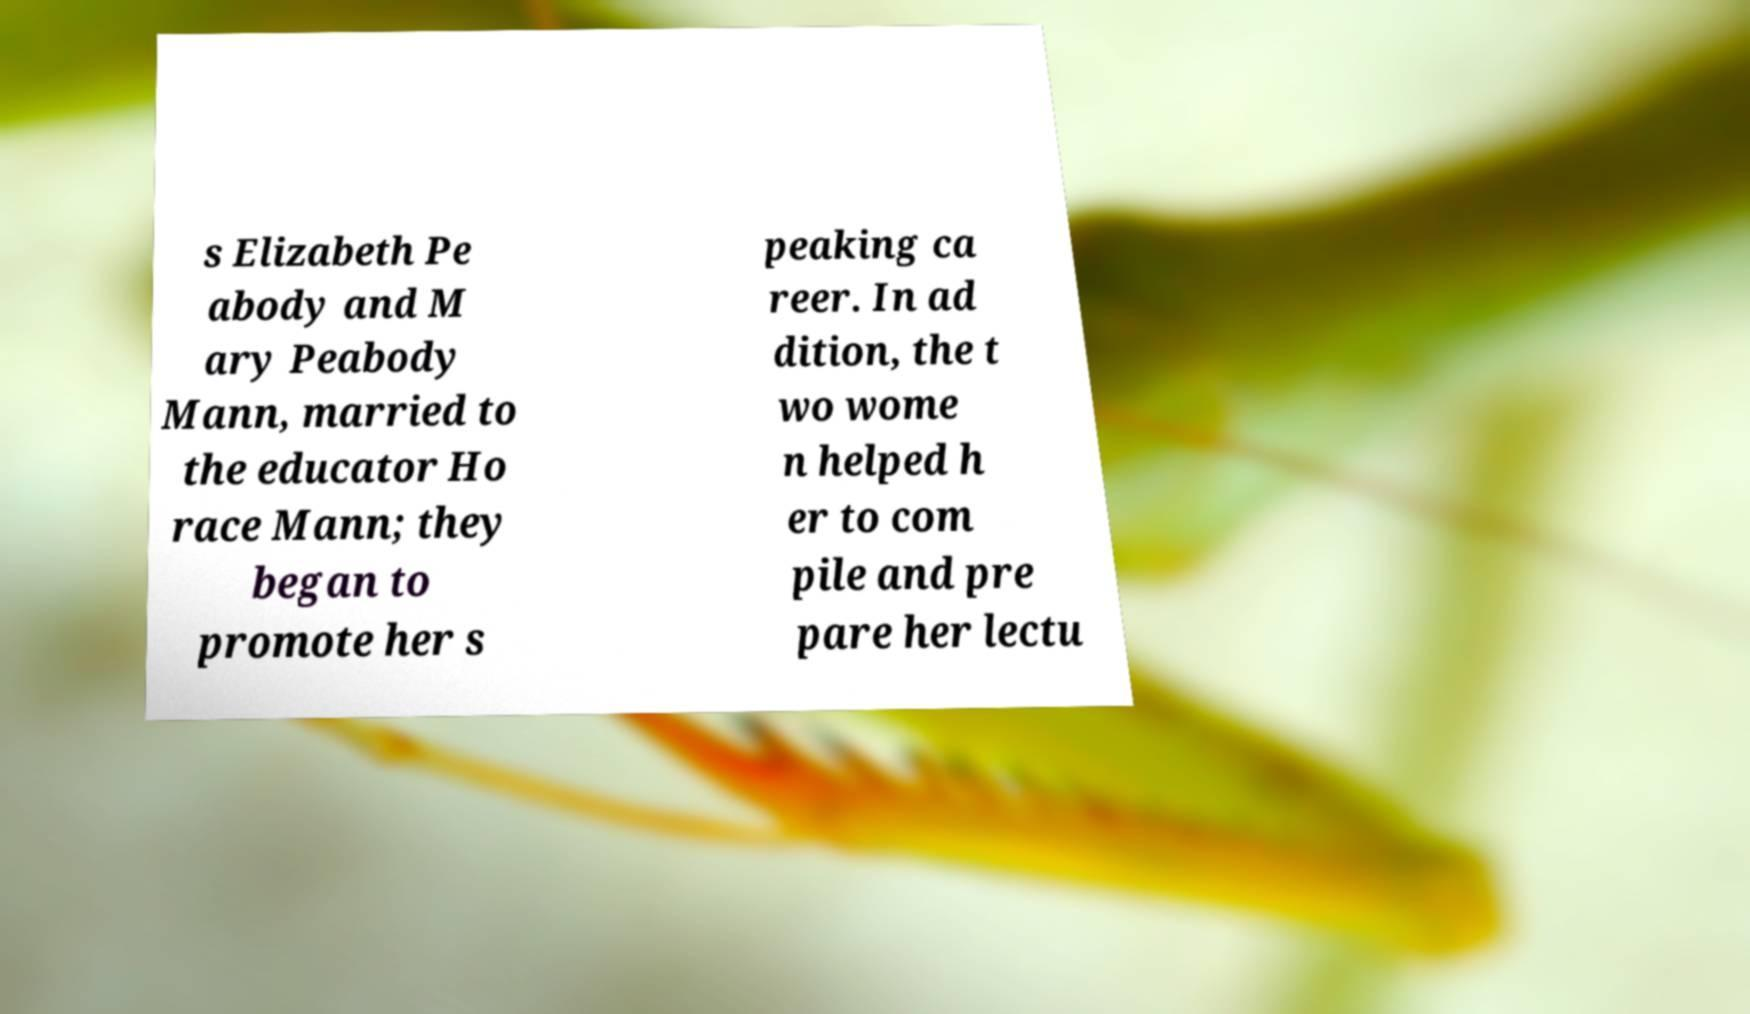I need the written content from this picture converted into text. Can you do that? s Elizabeth Pe abody and M ary Peabody Mann, married to the educator Ho race Mann; they began to promote her s peaking ca reer. In ad dition, the t wo wome n helped h er to com pile and pre pare her lectu 